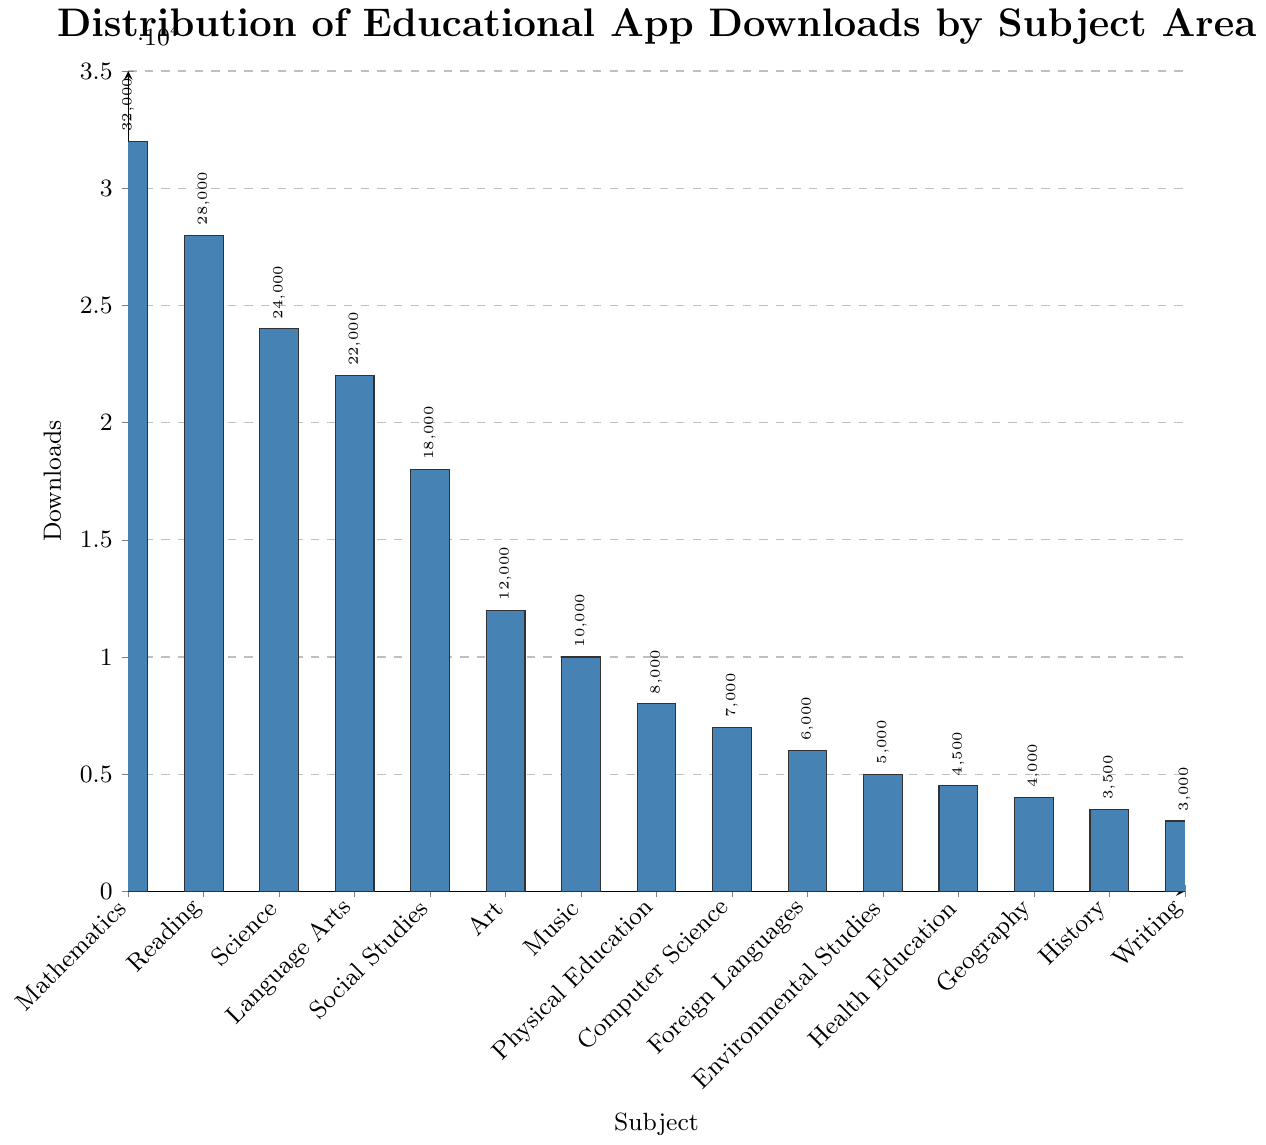Which subject has the highest number of downloads? The highest bar on the plot represents the subject with the most downloads. By visually inspecting the plot, the bar for Mathematics is the tallest.
Answer: Mathematics How many more downloads does Mathematics have compared to Reading? To find the difference, subtract the number of Reading downloads from the Mathematics downloads. Mathematics has 32000 downloads and Reading has 28000 downloads, so the difference is 32000 - 28000 = 4000.
Answer: 4000 What is the total number of downloads for Science, Social Studies, and Language Arts combined? Add the number of downloads for Science, Social Studies, and Language Arts together. Science has 24000 downloads, Social Studies has 18000, and Language Arts has 22000. The total is 24000 + 18000 + 22000 = 64000.
Answer: 64000 Which subjects have fewer than 5000 downloads? Identify the bars that are below the 5000 mark on the y-axis. The subjects with fewer than 5000 downloads are Geography (4000), History (3500), and Writing (3000).
Answer: Geography, History, Writing How many times more downloads does Mathematics have compared to Writing? Divide the number of downloads for Mathematics by the number of downloads for Writing. Mathematics has 32000 downloads and Writing has 3000 downloads, so 32000 / 3000 ≈ 10.67.
Answer: 10.67 Are there any subjects with an equal number of downloads? Visually inspect the plot for bars of equal height. There are no bars in the plot that have the same height, indicating no subjects have an equal number of downloads.
Answer: No What is the average number of downloads across all subjects? Calculate the average by summing the downloads of all subjects and then dividing by the number of subjects. The total sum is 32000 + 28000 + 24000 + 22000 + 18000 + 12000 + 10000 + 8000 + 7000 + 6000 + 5000 + 4500 + 4000 + 3500 + 3000 = 194000. The number of subjects is 15. Therefore, the average is 194000 / 15 ≈ 12933.
Answer: 12933 What is the minimum number of downloads among all subjects? Visually inspect the plot and find the shortest bar, which represents the minimum number of downloads. The shortest bar is for Writing, with 3000 downloads.
Answer: 3000 